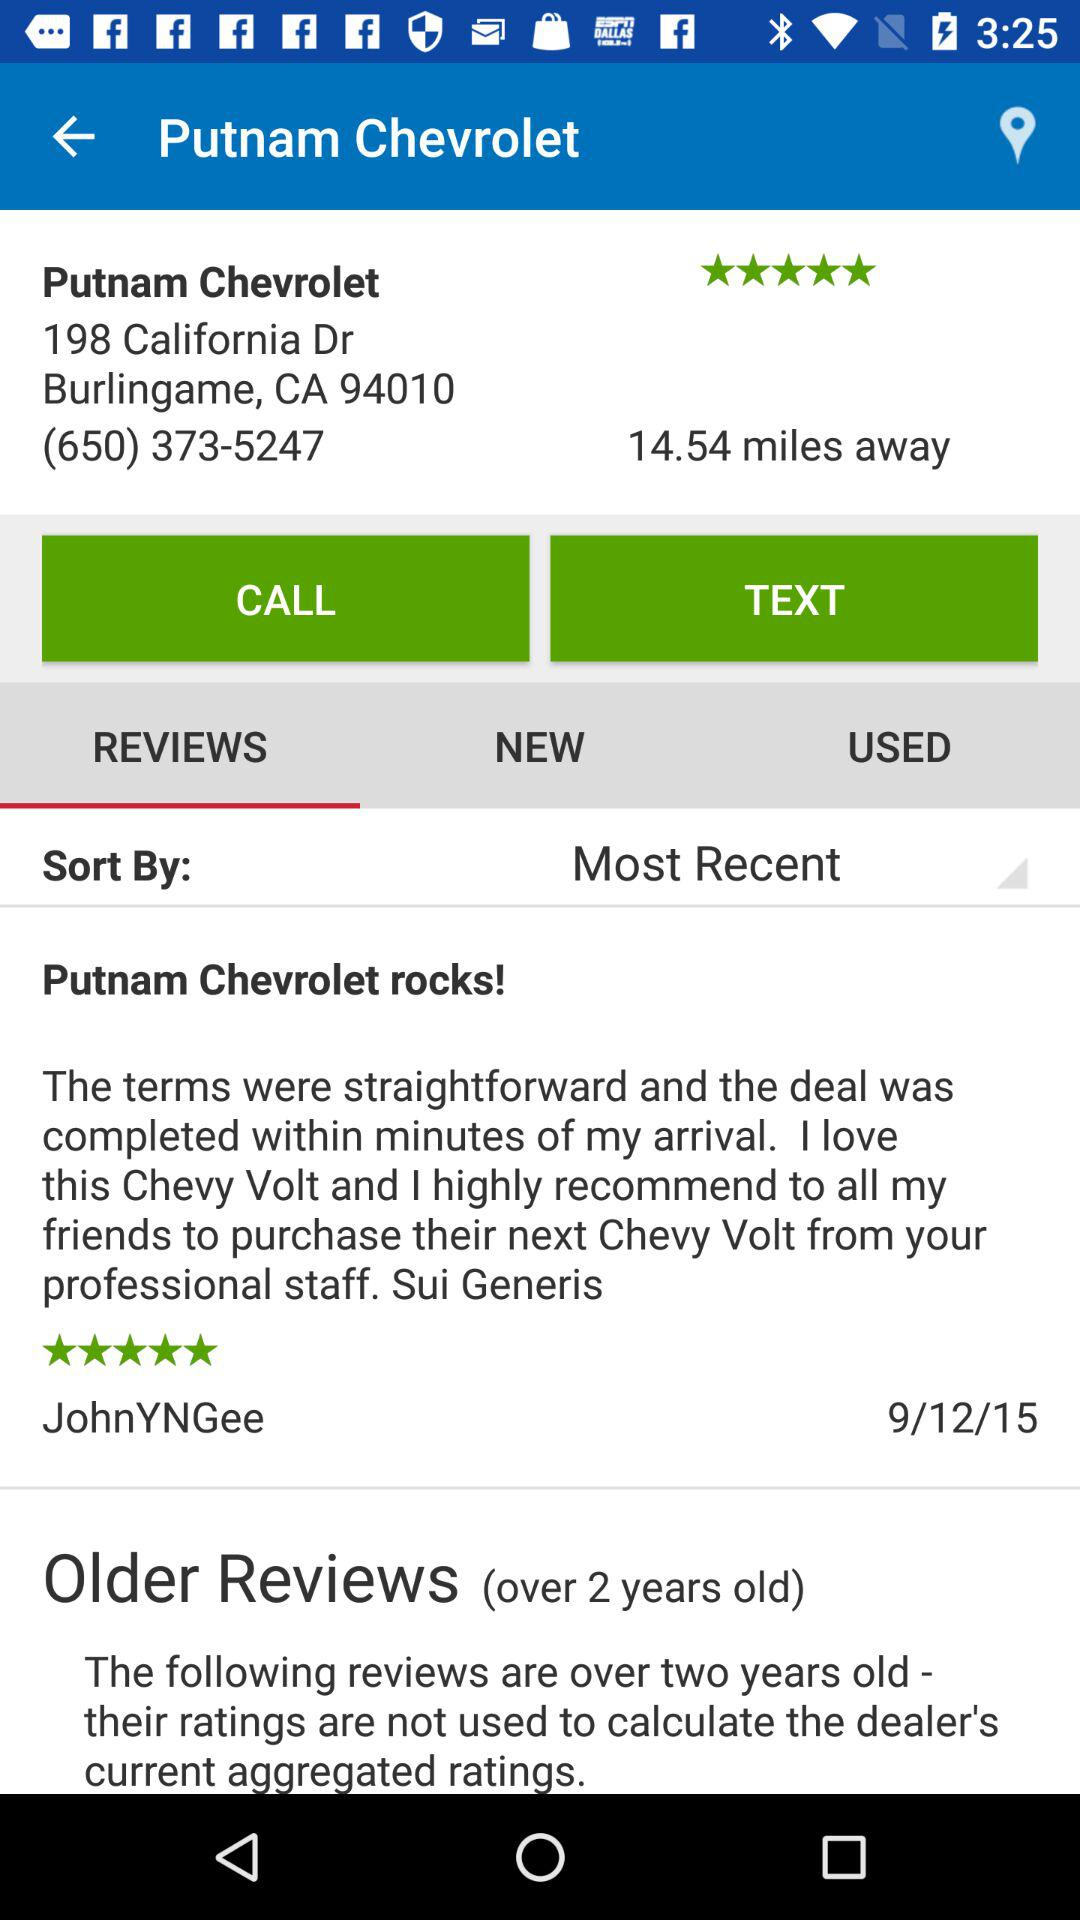Which tab is selected right now? The selected tab is "REVIEWS". 